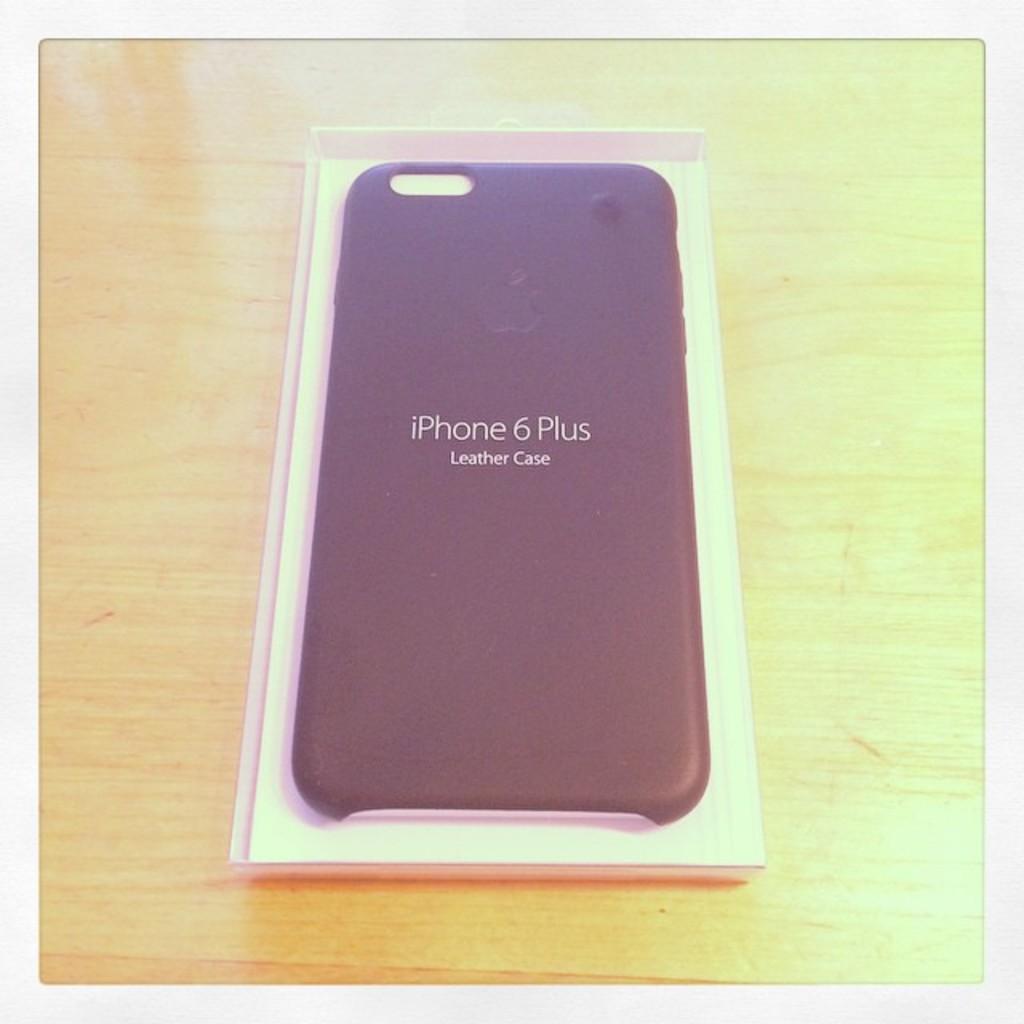What type of material is the case made of?
Give a very brief answer. Leather. What brand is this case for?
Your answer should be very brief. Iphone 6 plus. 